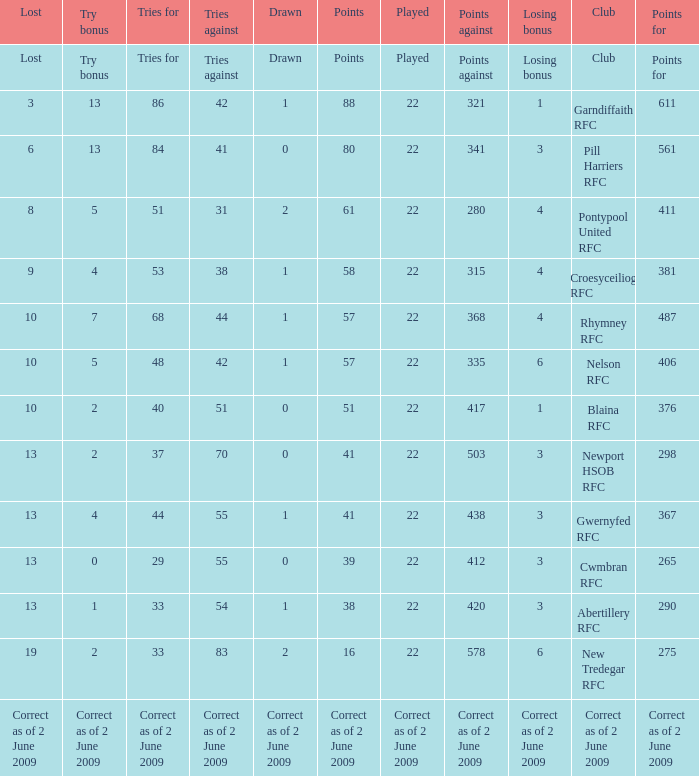Which club has 40 tries for? Blaina RFC. 